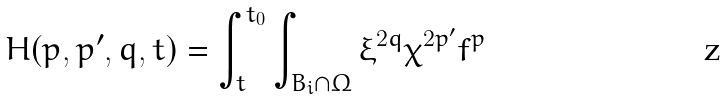<formula> <loc_0><loc_0><loc_500><loc_500>{ H ( p , p ^ { \prime } , q , t ) = \int _ { t } ^ { t _ { 0 } } \int _ { B _ { i } \cap \Omega } \xi ^ { 2 q } \chi ^ { 2 p ^ { \prime } } f ^ { p } }</formula> 